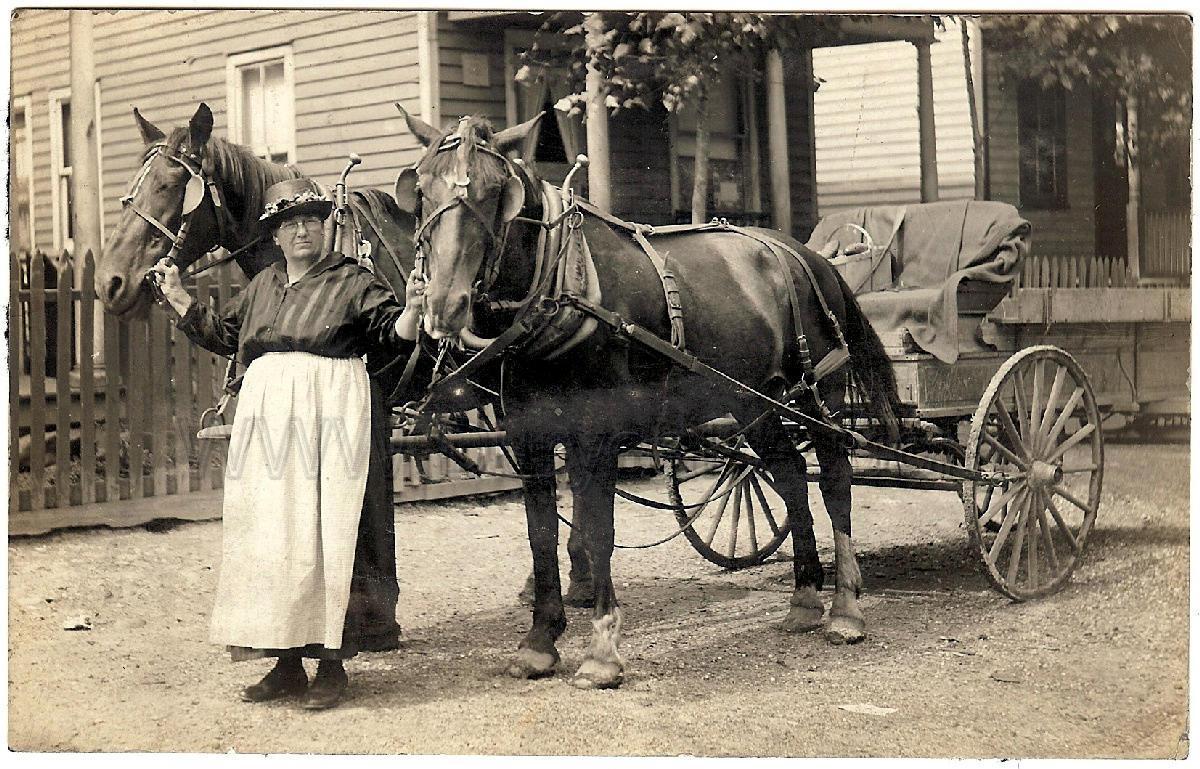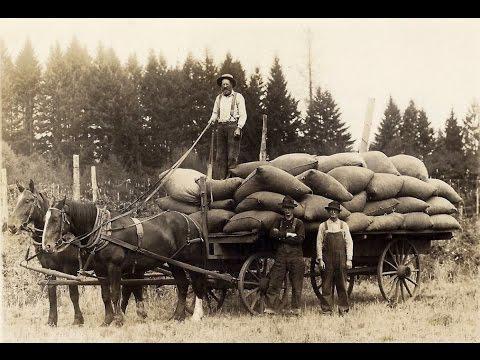The first image is the image on the left, the second image is the image on the right. For the images shown, is this caption "One image is of a horse-drawn cart with two wheels, while the other image is a larger horse-drawn wagon with four wheels." true? Answer yes or no. Yes. The first image is the image on the left, the second image is the image on the right. Analyze the images presented: Is the assertion "An image shows a left-facing horse-drawn cart with only two wheels." valid? Answer yes or no. Yes. 